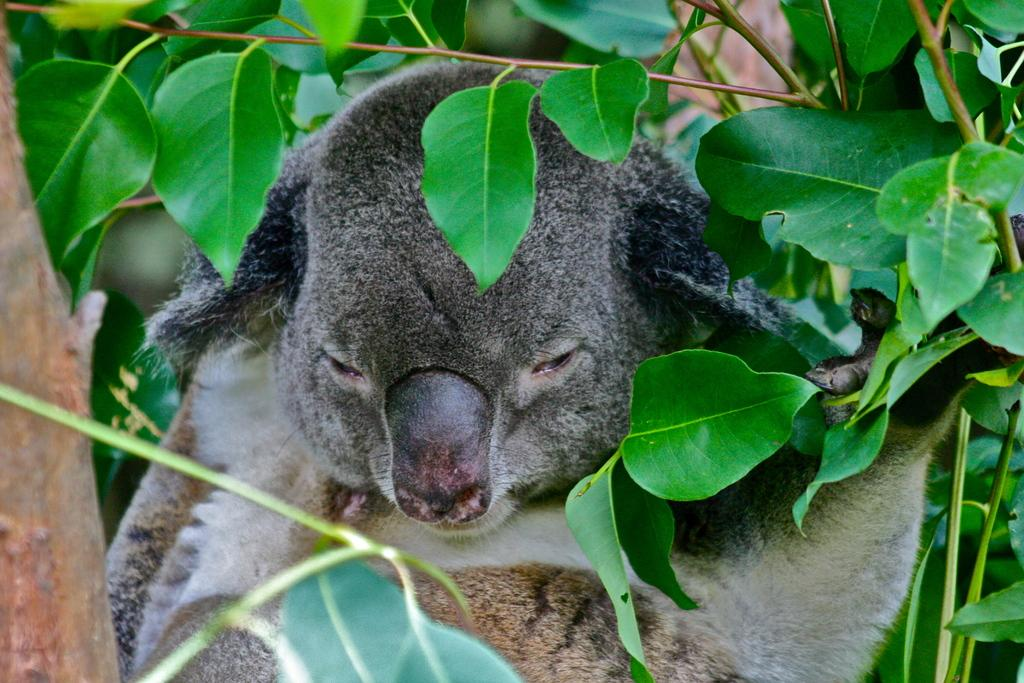What animal is in the image? There is a koala in the image. Where is the koala located? The koala is on a tree. What can be seen around the koala? There are leaves around the koala. What type of harbor can be seen in the image? There is no harbor present in the image; it features a koala on a tree with leaves around it. How many ladybugs are visible on the koala in the image? There are no ladybugs visible on the koala in the image. 